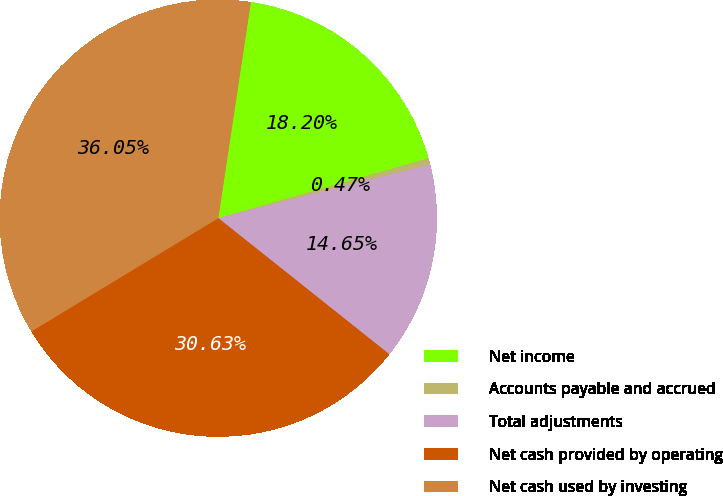<chart> <loc_0><loc_0><loc_500><loc_500><pie_chart><fcel>Net income<fcel>Accounts payable and accrued<fcel>Total adjustments<fcel>Net cash provided by operating<fcel>Net cash used by investing<nl><fcel>18.2%<fcel>0.47%<fcel>14.65%<fcel>30.63%<fcel>36.05%<nl></chart> 